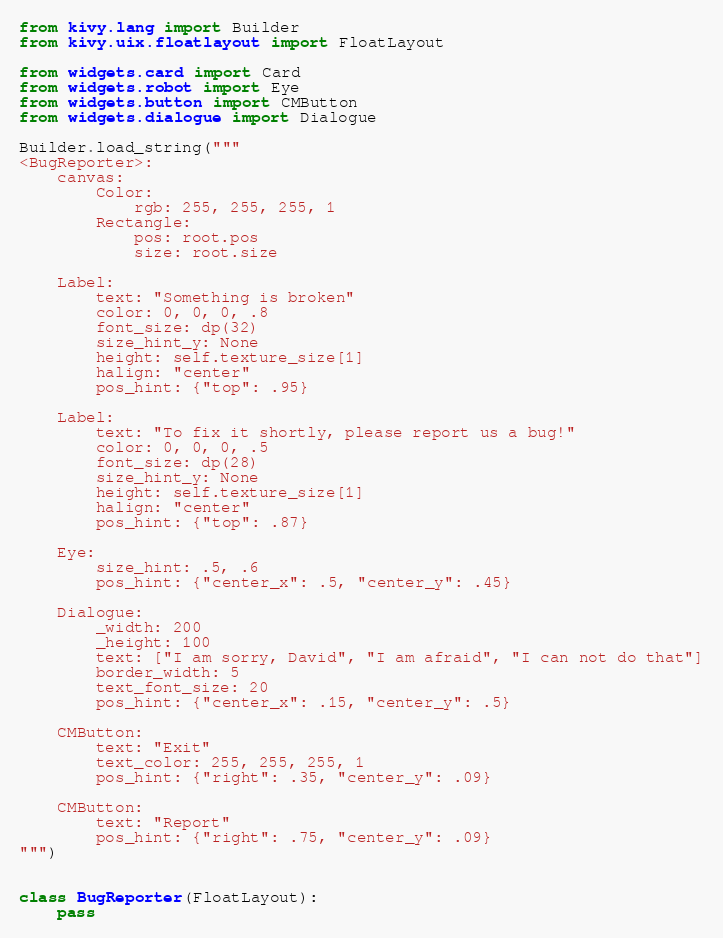<code> <loc_0><loc_0><loc_500><loc_500><_Python_>from kivy.lang import Builder
from kivy.uix.floatlayout import FloatLayout

from widgets.card import Card
from widgets.robot import Eye
from widgets.button import CMButton
from widgets.dialogue import Dialogue

Builder.load_string("""
<BugReporter>:
	canvas:
		Color:
			rgb: 255, 255, 255, 1
		Rectangle:
			pos: root.pos
			size: root.size

	Label:
		text: "Something is broken"
		color: 0, 0, 0, .8
		font_size: dp(32)
		size_hint_y: None
		height: self.texture_size[1]
		halign: "center"
		pos_hint: {"top": .95}

	Label:
		text: "To fix it shortly, please report us a bug!"
		color: 0, 0, 0, .5
		font_size: dp(28)
		size_hint_y: None
		height: self.texture_size[1]
		halign: "center"
		pos_hint: {"top": .87}

	Eye:
		size_hint: .5, .6
		pos_hint: {"center_x": .5, "center_y": .45}

	Dialogue:
		_width: 200
		_height: 100
		text: ["I am sorry, David", "I am afraid", "I can not do that"]
		border_width: 5
		text_font_size: 20
		pos_hint: {"center_x": .15, "center_y": .5}

	CMButton:
		text: "Exit"
		text_color: 255, 255, 255, 1
		pos_hint: {"right": .35, "center_y": .09}

	CMButton:
		text: "Report"
		pos_hint: {"right": .75, "center_y": .09}
""")


class BugReporter(FloatLayout):
	pass</code> 